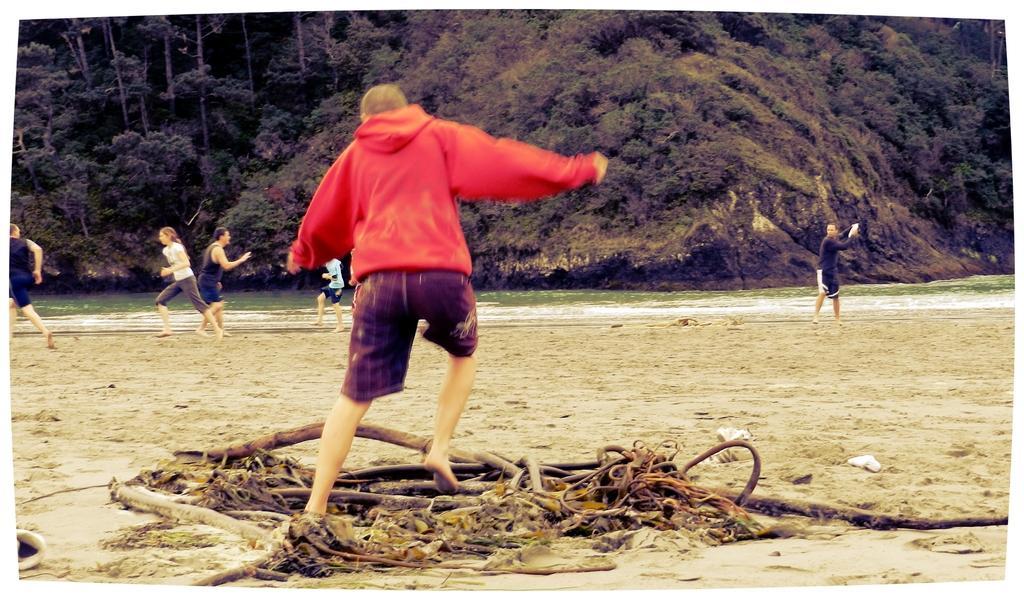How would you summarize this image in a sentence or two? In the image few people are standing and running. Behind them there is water and there are some trees and hills. 